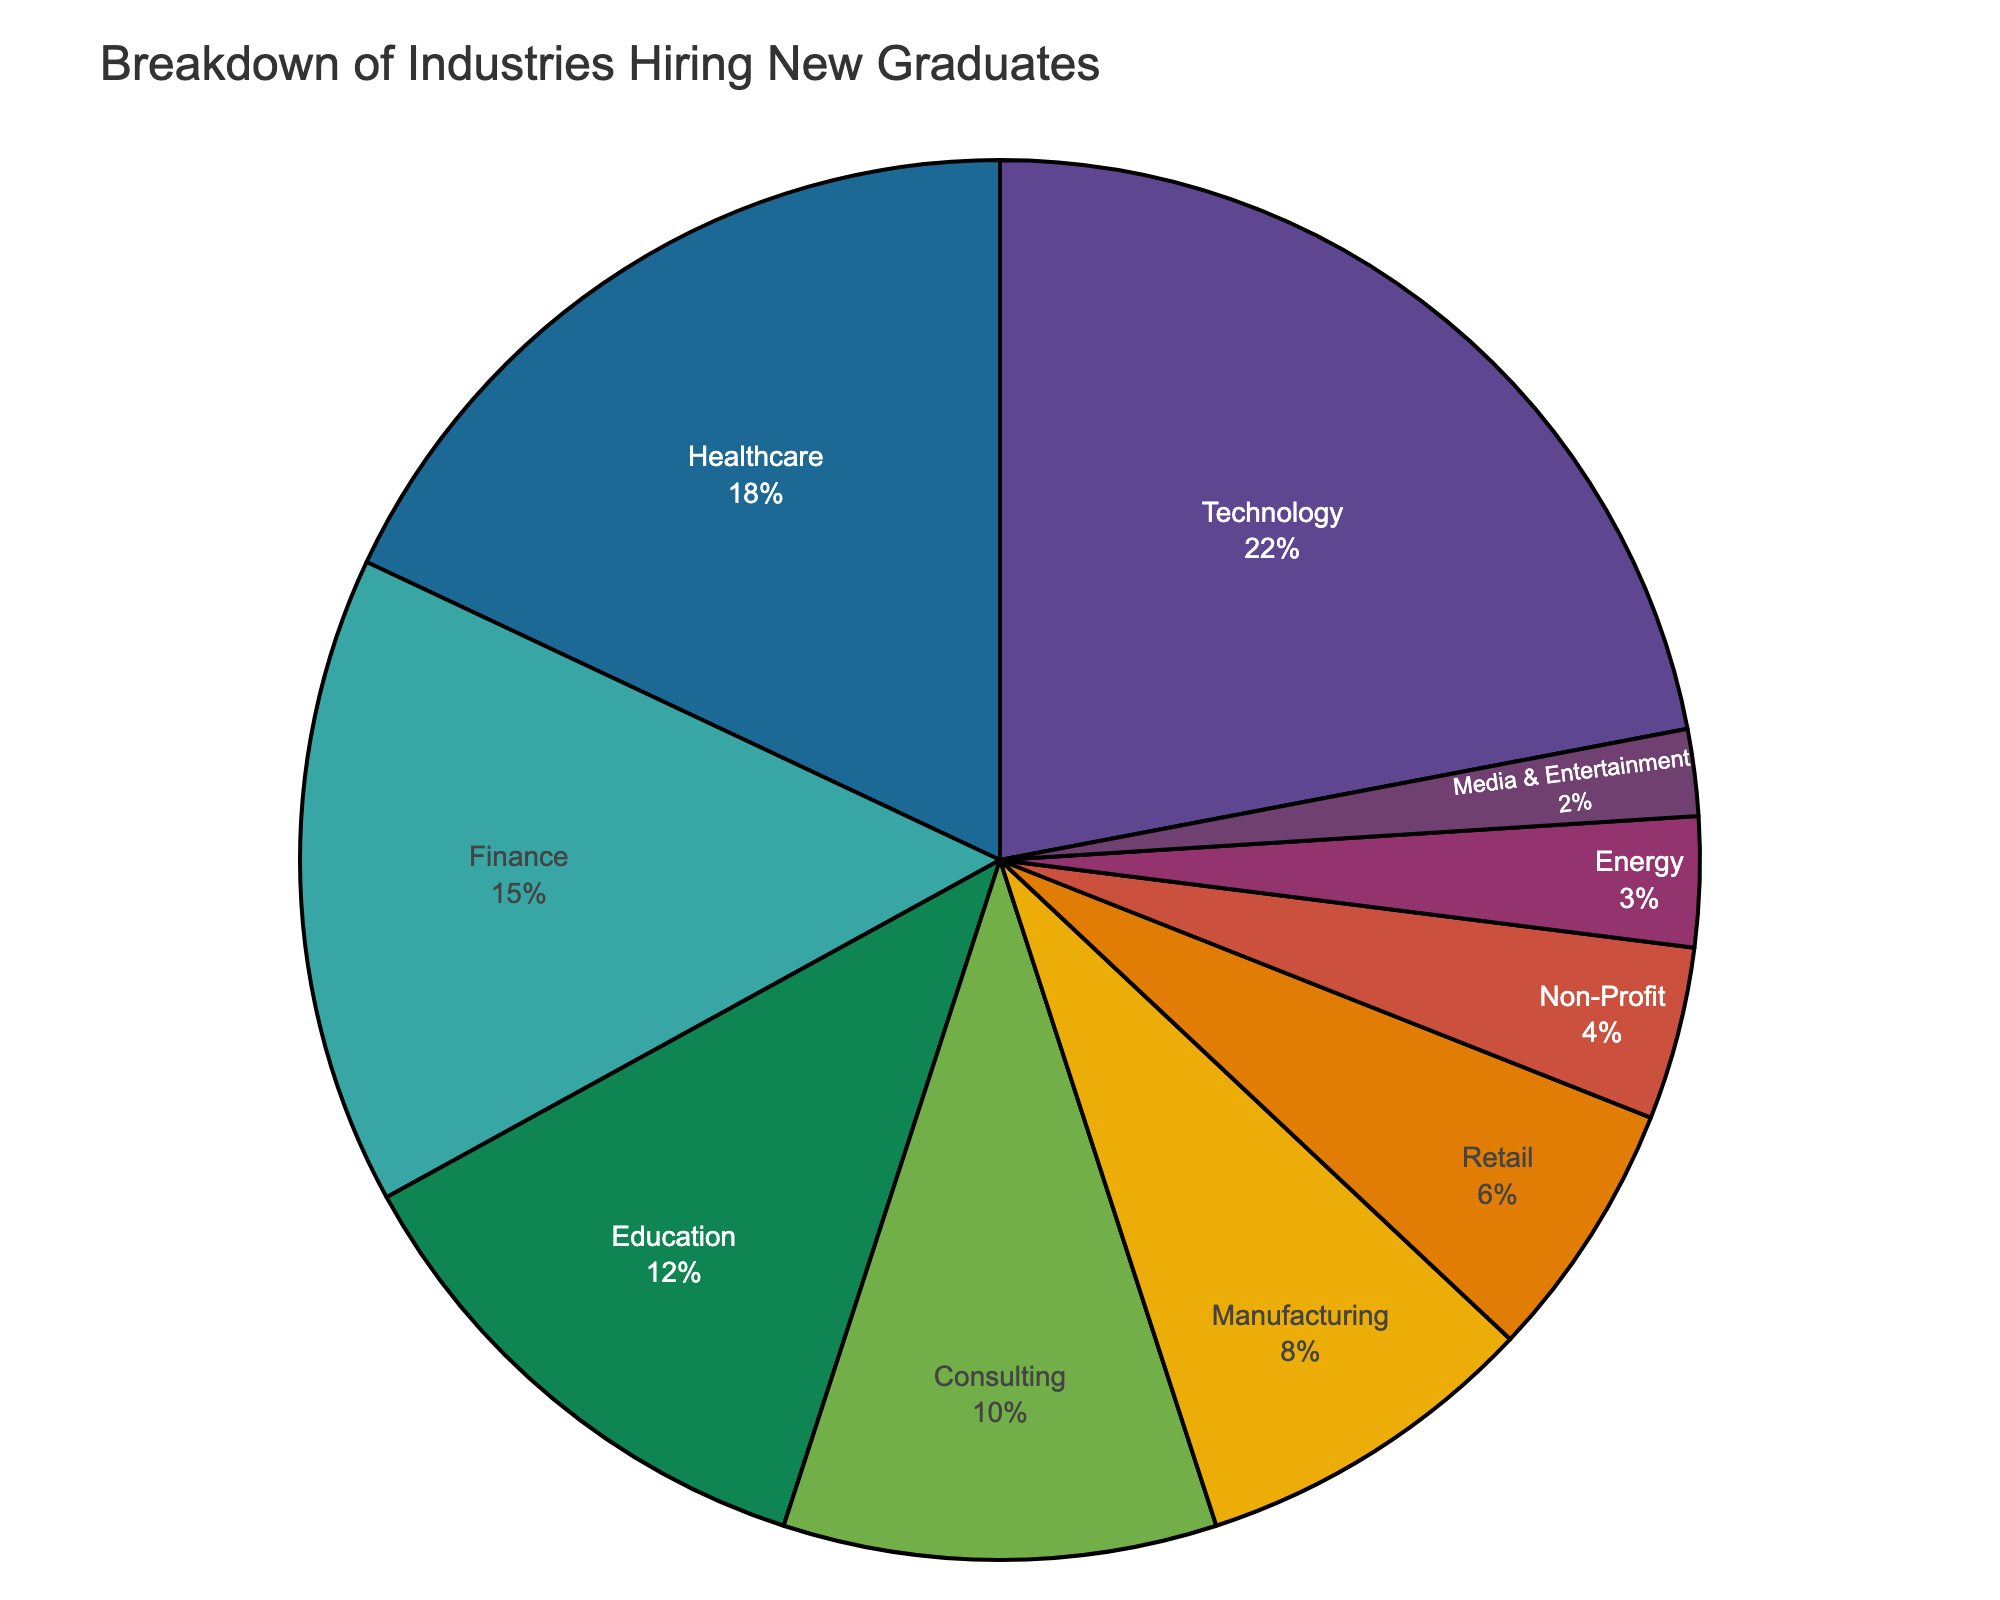What's the industry with the highest hiring percentage? The largest section of the pie chart corresponds to the Technology industry. By looking at the percentages listed or visually identifying the largest slice, one can see that Technology stands out.
Answer: Technology Which two industries combined make up exactly 30% of the hiring? By adding percentages from the pie chart, the sum of Finance (15%) and Education (15%) equals 30%. This is verified visually and by arithmetic.
Answer: Finance and Education What is the difference in hiring percentages between Technology and Manufacturing? The pie chart shows Technology at 22% and Manufacturing at 8%. The difference is calculated as 22% - 8% = 14%.
Answer: 14% Which industries have hiring percentages less than 5%? By identifying the sectors with percentages below 5%, the Non-Profit, Energy, and Media & Entertainment industries meet this criterion based on their visual and numerical representation on the pie chart.
Answer: Non-Profit, Energy, Media & Entertainment How many industries hire more than 10% of new graduates? Checking the pie chart for sectors exceeding 10%: Technology (22%), Healthcare (18%), Finance (15%), and Education (12%) all surpass this threshold.
Answer: 4 What's the combined hiring percentage for the top three industries? Adding the percentages of Technology (22%), Healthcare (18%), and Finance (15%) results in a total of 22% + 18% + 15% = 55%.
Answer: 55% Which industry is the smallest in terms of hiring percentage? The smallest section on the pie chart is the Media & Entertainment sector, with a hiring percentage of 2%.
Answer: Media & Entertainment Between Consulting and Retail, which industry hires more new graduates? Consulting has a hiring percentage of 10%, whereas Retail has 6%. Consulting hires more graduates than Retail.
Answer: Consulting What’s the difference between the hiring percentages of Healthcare and Education? Healthcare has 18% and Education has 12%. The difference is calculated as 18% - 12% = 6%.
Answer: 6% 